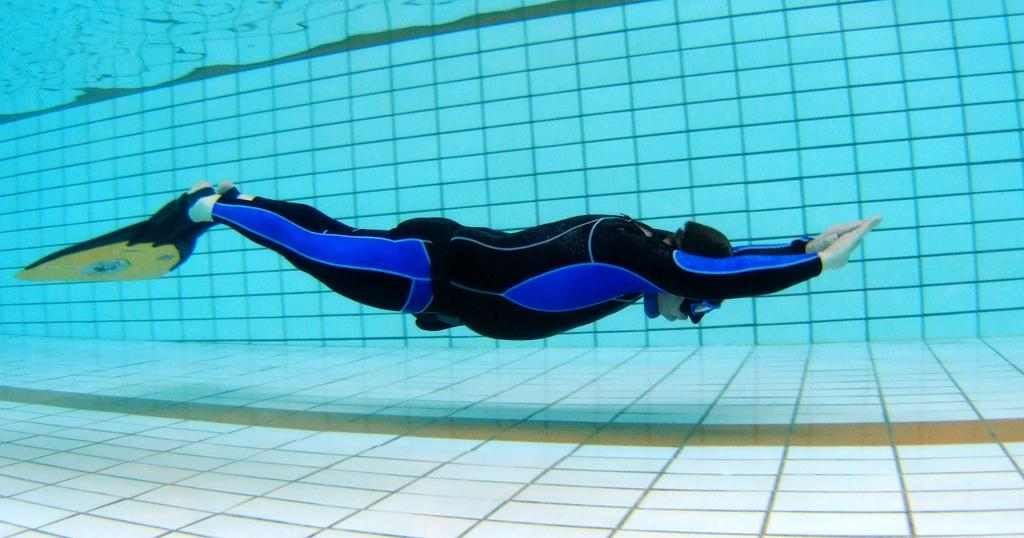What type of flooring is visible in the image? There are white color tiles in the image. What else can be seen in the image besides the tiles? There is water visible in the image. Can you describe the person in the image? There is a man in the image, and he is wearing a black color swim suit. Are there any sheep visible in the image? No, there are no sheep present in the image. 